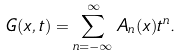Convert formula to latex. <formula><loc_0><loc_0><loc_500><loc_500>G ( x , t ) = \sum _ { n = - { \infty } } ^ { \infty } A _ { n } ( x ) t ^ { n } .</formula> 